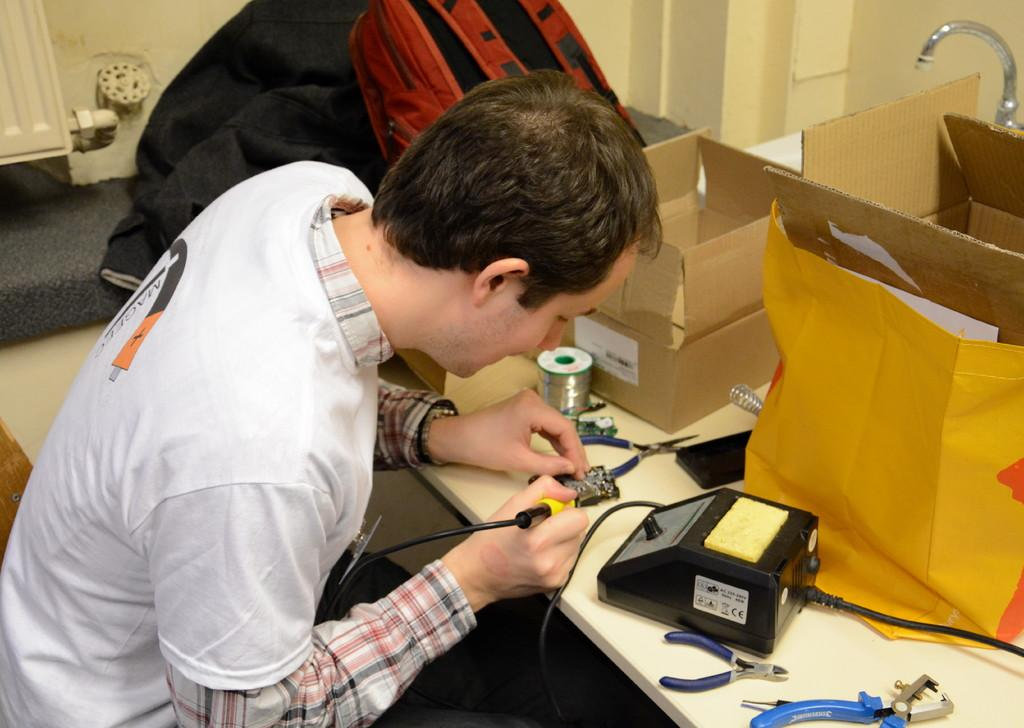What is the person in the image doing? The person is working in the image. What material is the person working on? The person is working on a chipboard. What tools or equipment can be seen in the image? A machine, a screwdriver, and a wire roll are present in the image. What type of container is visible in the image? A cardboard box is visible in the image. What protective covering is present in the image? There is a paper cover in the image. What personal belongings can be seen in the image? A backpack and a jacket are present in the image. What type of chin can be seen on the goat in the image? There is no goat present in the image, and therefore no chin can be observed. What type of rhythm is the person working to in the image? There is no indication of any rhythm or music in the image, so it cannot be determined. 